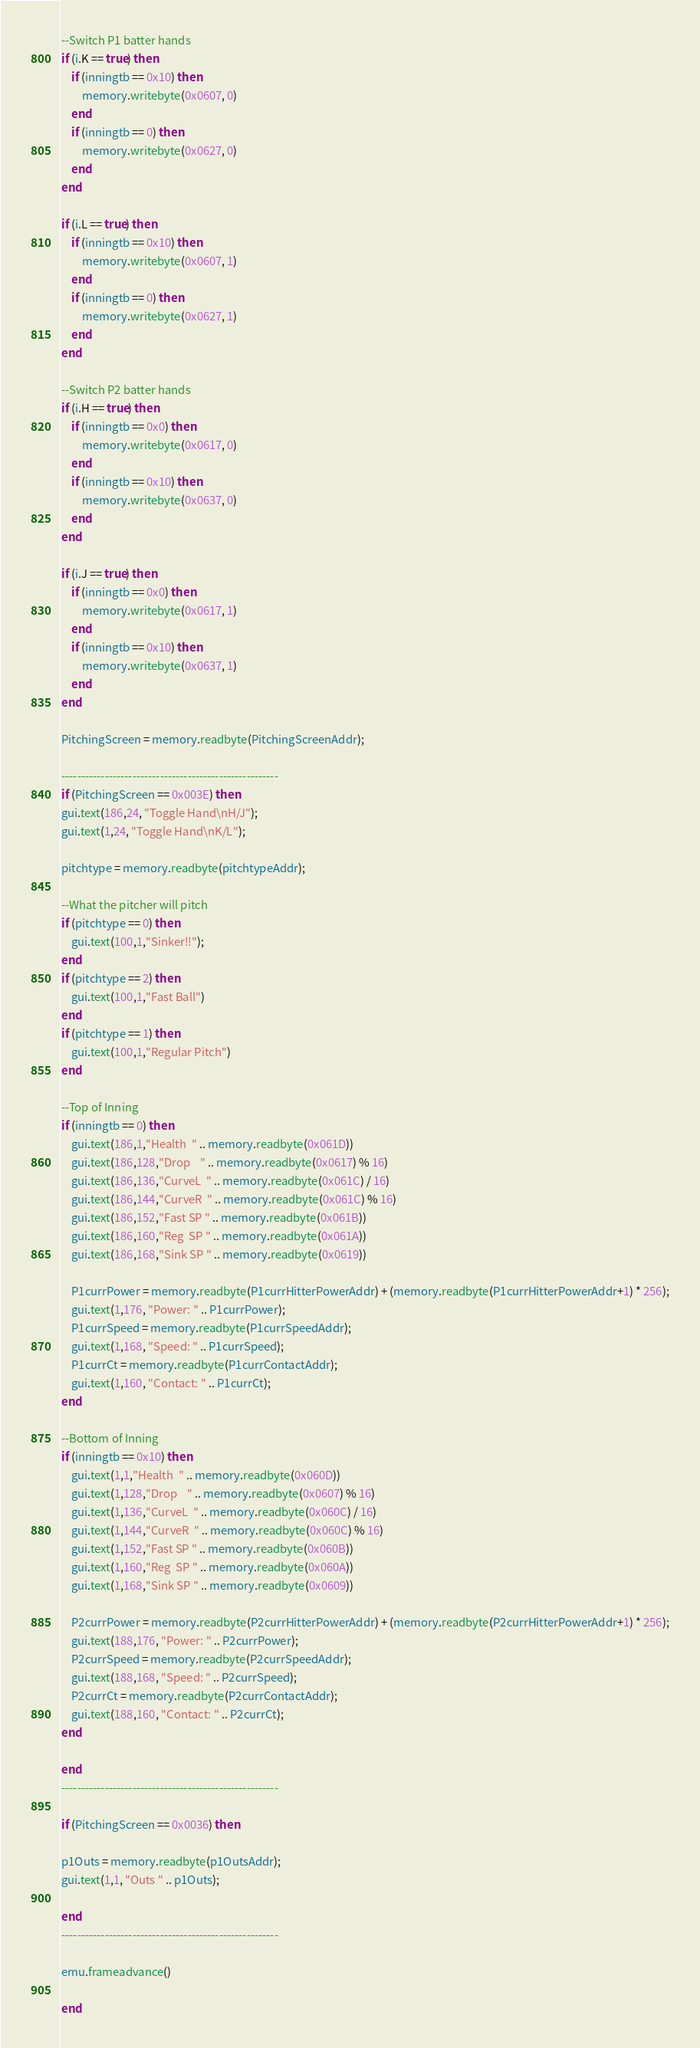Convert code to text. <code><loc_0><loc_0><loc_500><loc_500><_Lua_>
--Switch P1 batter hands
if (i.K == true) then
	if (inningtb == 0x10) then	
		memory.writebyte(0x0607, 0)
	end
	if (inningtb == 0) then
		memory.writebyte(0x0627, 0)
	end
end
	
if (i.L == true) then
	if (inningtb == 0x10) then	
		memory.writebyte(0x0607, 1)
	end
	if (inningtb == 0) then
		memory.writebyte(0x0627, 1)
	end
end

--Switch P2 batter hands
if (i.H == true) then
	if (inningtb == 0x0) then	
		memory.writebyte(0x0617, 0)
	end
	if (inningtb == 0x10) then
		memory.writebyte(0x0637, 0)
	end
end
	
if (i.J == true) then
	if (inningtb == 0x0) then	
		memory.writebyte(0x0617, 1)
	end
	if (inningtb == 0x10) then
		memory.writebyte(0x0637, 1)
	end
end
	
PitchingScreen = memory.readbyte(PitchingScreenAddr);

-------------------------------------------------------
if (PitchingScreen == 0x003E) then
gui.text(186,24, "Toggle Hand\nH/J");
gui.text(1,24, "Toggle Hand\nK/L");

pitchtype = memory.readbyte(pitchtypeAddr);

--What the pitcher will pitch
if (pitchtype == 0) then
	gui.text(100,1,"Sinker!!");
end
if (pitchtype == 2) then
	gui.text(100,1,"Fast Ball")
end
if (pitchtype == 1) then
	gui.text(100,1,"Regular Pitch")
end

--Top of Inning
if (inningtb == 0) then
	gui.text(186,1,"Health  " .. memory.readbyte(0x061D))
	gui.text(186,128,"Drop    " .. memory.readbyte(0x0617) % 16)
	gui.text(186,136,"CurveL  " .. memory.readbyte(0x061C) / 16)
	gui.text(186,144,"CurveR  " .. memory.readbyte(0x061C) % 16)
	gui.text(186,152,"Fast SP " .. memory.readbyte(0x061B))
	gui.text(186,160,"Reg  SP " .. memory.readbyte(0x061A))
	gui.text(186,168,"Sink SP " .. memory.readbyte(0x0619))
	
	P1currPower = memory.readbyte(P1currHitterPowerAddr) + (memory.readbyte(P1currHitterPowerAddr+1) * 256);
	gui.text(1,176, "Power: " .. P1currPower);
	P1currSpeed = memory.readbyte(P1currSpeedAddr);
	gui.text(1,168, "Speed: " .. P1currSpeed);
	P1currCt = memory.readbyte(P1currContactAddr);
	gui.text(1,160, "Contact: " .. P1currCt);
end

--Bottom of Inning
if (inningtb == 0x10) then
	gui.text(1,1,"Health  " .. memory.readbyte(0x060D))
	gui.text(1,128,"Drop    " .. memory.readbyte(0x0607) % 16)
	gui.text(1,136,"CurveL  " .. memory.readbyte(0x060C) / 16)
	gui.text(1,144,"CurveR  " .. memory.readbyte(0x060C) % 16)
	gui.text(1,152,"Fast SP " .. memory.readbyte(0x060B))
	gui.text(1,160,"Reg  SP " .. memory.readbyte(0x060A))
	gui.text(1,168,"Sink SP " .. memory.readbyte(0x0609))

	P2currPower = memory.readbyte(P2currHitterPowerAddr) + (memory.readbyte(P2currHitterPowerAddr+1) * 256);
	gui.text(188,176, "Power: " .. P2currPower);
	P2currSpeed = memory.readbyte(P2currSpeedAddr);
	gui.text(188,168, "Speed: " .. P2currSpeed);
	P2currCt = memory.readbyte(P2currContactAddr);
	gui.text(188,160, "Contact: " .. P2currCt);
end

end
-------------------------------------------------------

if (PitchingScreen == 0x0036) then

p1Outs = memory.readbyte(p1OutsAddr);
gui.text(1,1, "Outs " .. p1Outs);

end
-------------------------------------------------------

emu.frameadvance()

end</code> 